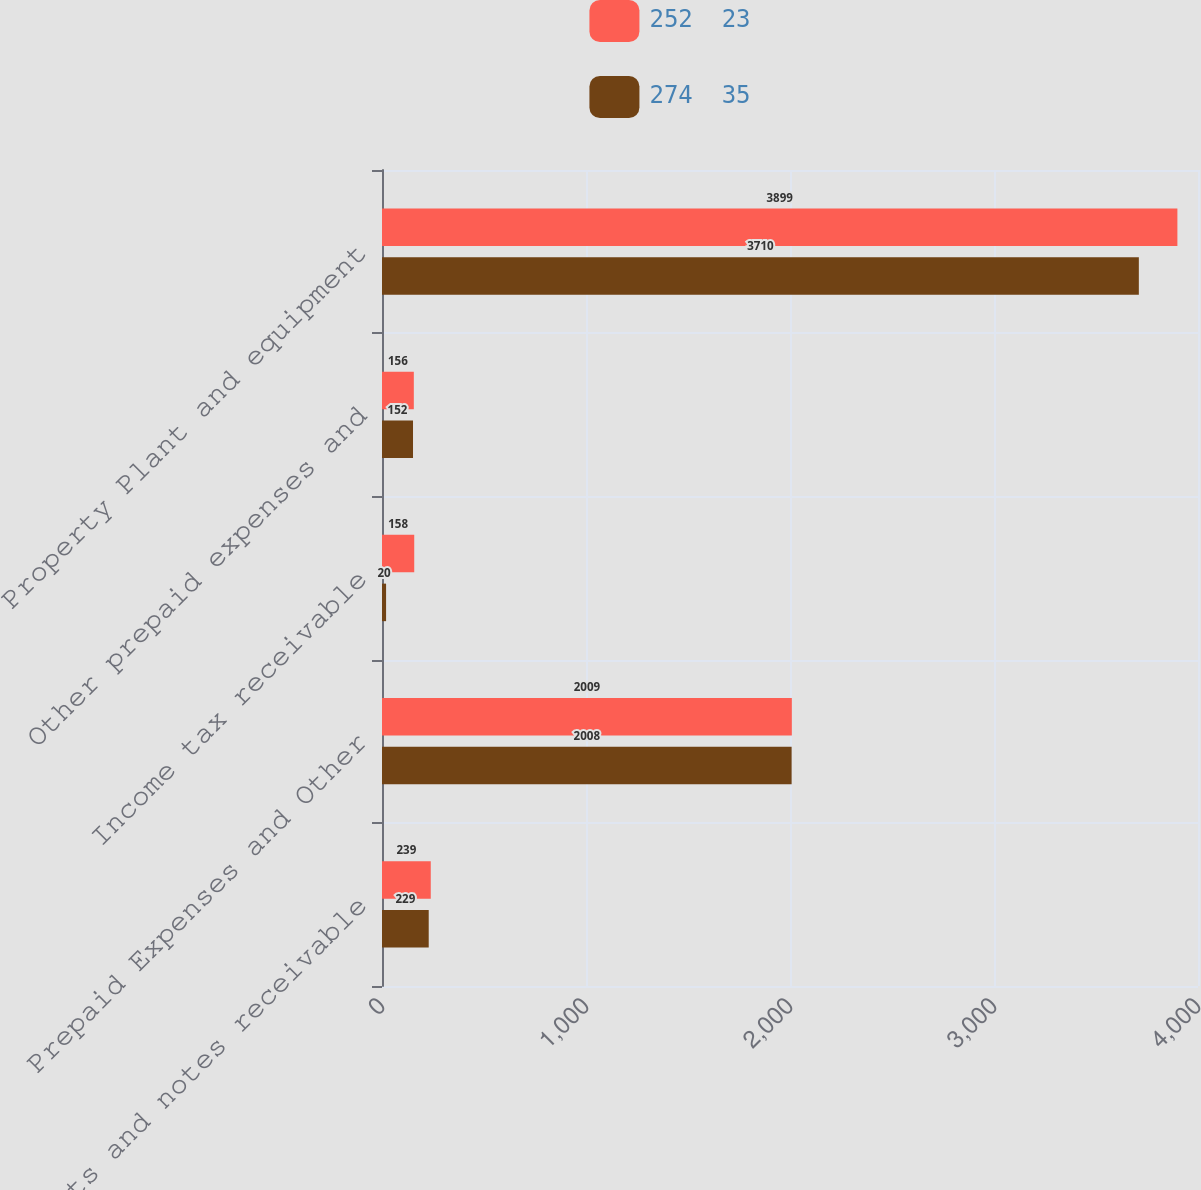Convert chart. <chart><loc_0><loc_0><loc_500><loc_500><stacked_bar_chart><ecel><fcel>Accounts and notes receivable<fcel>Prepaid Expenses and Other<fcel>Income tax receivable<fcel>Other prepaid expenses and<fcel>Property Plant and equipment<nl><fcel>252  23<fcel>239<fcel>2009<fcel>158<fcel>156<fcel>3899<nl><fcel>274  35<fcel>229<fcel>2008<fcel>20<fcel>152<fcel>3710<nl></chart> 